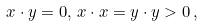<formula> <loc_0><loc_0><loc_500><loc_500>x \cdot y = 0 , \, x \cdot x = y \cdot y > 0 \, ,</formula> 